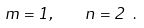Convert formula to latex. <formula><loc_0><loc_0><loc_500><loc_500>m = 1 , \quad n = 2 \ .</formula> 